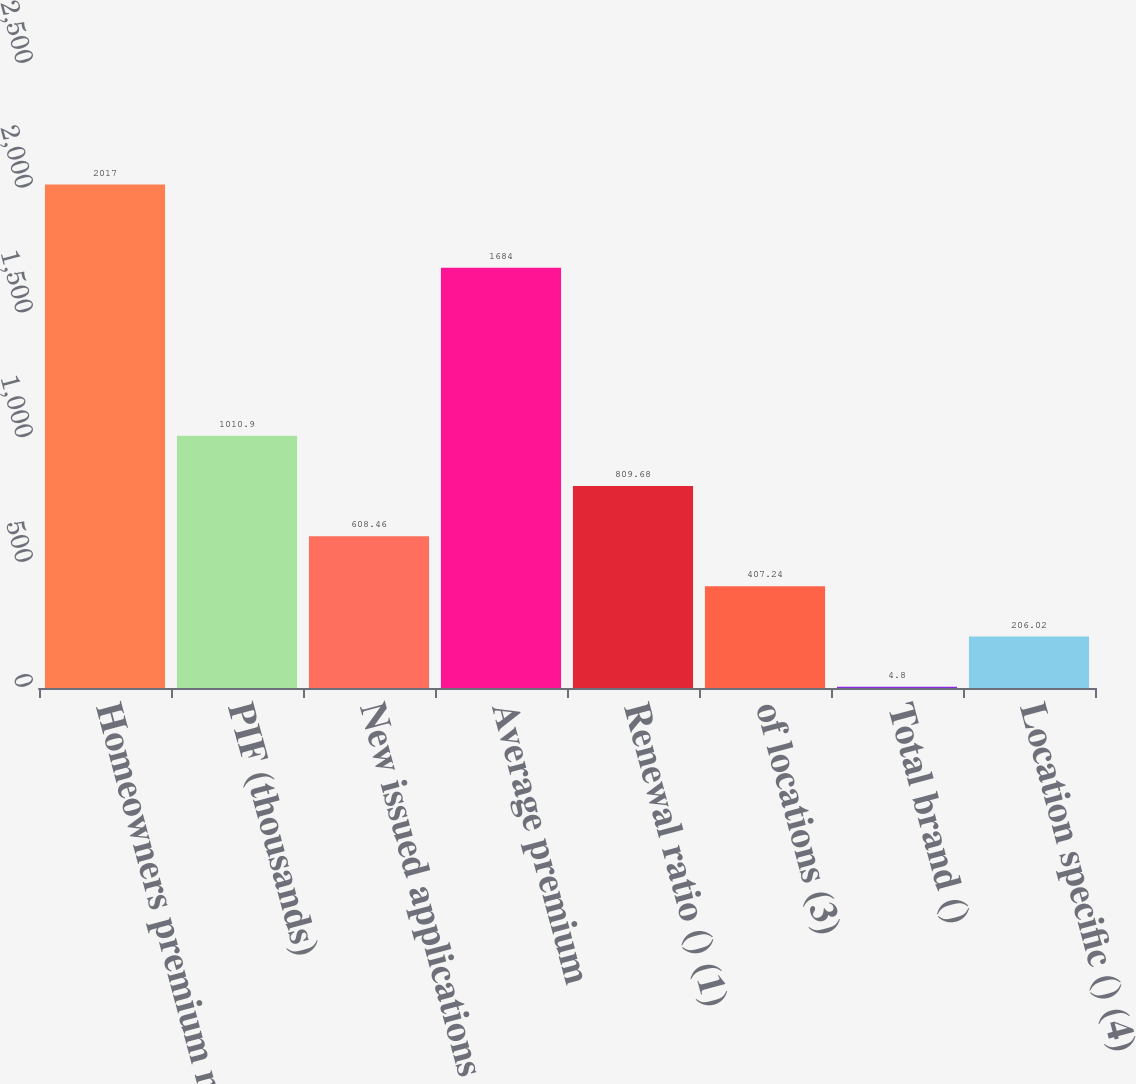Convert chart. <chart><loc_0><loc_0><loc_500><loc_500><bar_chart><fcel>Homeowners premium measure and<fcel>PIF (thousands)<fcel>New issued applications<fcel>Average premium<fcel>Renewal ratio () (1)<fcel>of locations (3)<fcel>Total brand ()<fcel>Location specific () (4)<nl><fcel>2017<fcel>1010.9<fcel>608.46<fcel>1684<fcel>809.68<fcel>407.24<fcel>4.8<fcel>206.02<nl></chart> 